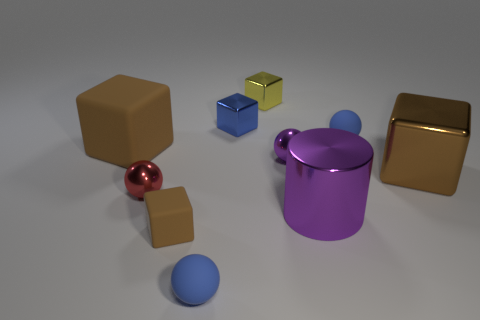There is a matte thing behind the matte block that is behind the large brown thing to the right of the big matte object; what is its shape?
Provide a short and direct response. Sphere. What is the block that is left of the brown metallic thing and in front of the large matte object made of?
Offer a very short reply. Rubber. There is a large block that is on the left side of the brown thing right of the tiny blue matte object on the right side of the yellow thing; what is its color?
Give a very brief answer. Brown. How many blue things are either large objects or small rubber cubes?
Give a very brief answer. 0. What number of other objects are the same size as the purple ball?
Your answer should be very brief. 6. What number of tiny yellow metallic objects are there?
Provide a succinct answer. 1. Are there any other things that are the same shape as the big purple thing?
Give a very brief answer. No. Is the big thing that is on the left side of the red shiny sphere made of the same material as the large thing in front of the big brown metallic block?
Provide a short and direct response. No. What is the small purple sphere made of?
Provide a short and direct response. Metal. What number of purple blocks have the same material as the small yellow block?
Offer a terse response. 0. 